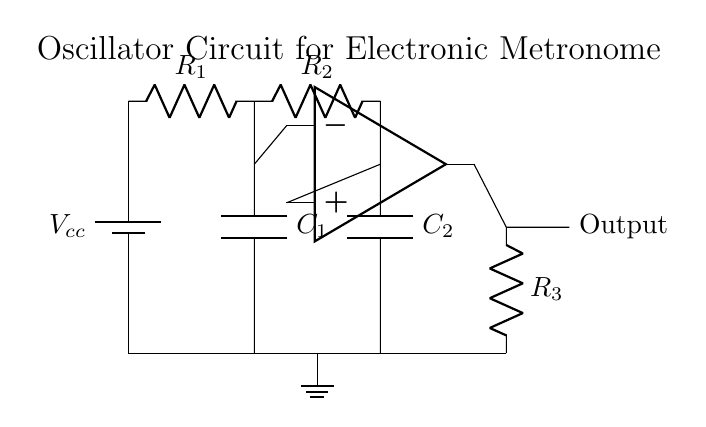What type of circuit is this? This circuit is an oscillator circuit, which is often used to produce a periodic signal. The presence of resistors, capacitors, and an op-amp indicates that it is designed to generate oscillations for applications like a metronome.
Answer: oscillator circuit What components make up this circuit? The circuit comprises a battery, resistors (R1, R2, R3), capacitors (C1, C2), and an operational amplifier (op-amp). These components work together to create oscillation behavior necessary for the metronome function.
Answer: battery, resistors, capacitors, op-amp What is the function of the op-amp in this circuit? The op-amp functions as a comparator and amplifier, helping to shape the oscillation signals generated by the circuit. It amplifies the feedback from the resistors and capacitors to sustain oscillation and ensure a stable output.
Answer: comparator and amplifier How many capacitors are in this circuit? There are two capacitors in the circuit, labeled C1 and C2, which are crucial for controlling the timing of the oscillator and thus determining the frequency of the output signal.
Answer: two Explain how the output signal is generated. The output signal is generated through the interactions between the resistors and capacitors, which create a feedback loop in conjunction with the op-amp. The op-amp amplifies the resulting voltage changes, creating a square wave output, which is characteristic for timing applications like a metronome.
Answer: feedback loop and square wave signal What determines the frequency of oscillation? The frequency of oscillation in this circuit is determined by the values of the resistors (R1, R2, R3) and capacitors (C1, C2). The relationship between these components sets the time constant of the oscillations, influencing how quickly the circuit cycles.
Answer: resistor and capacitor values 